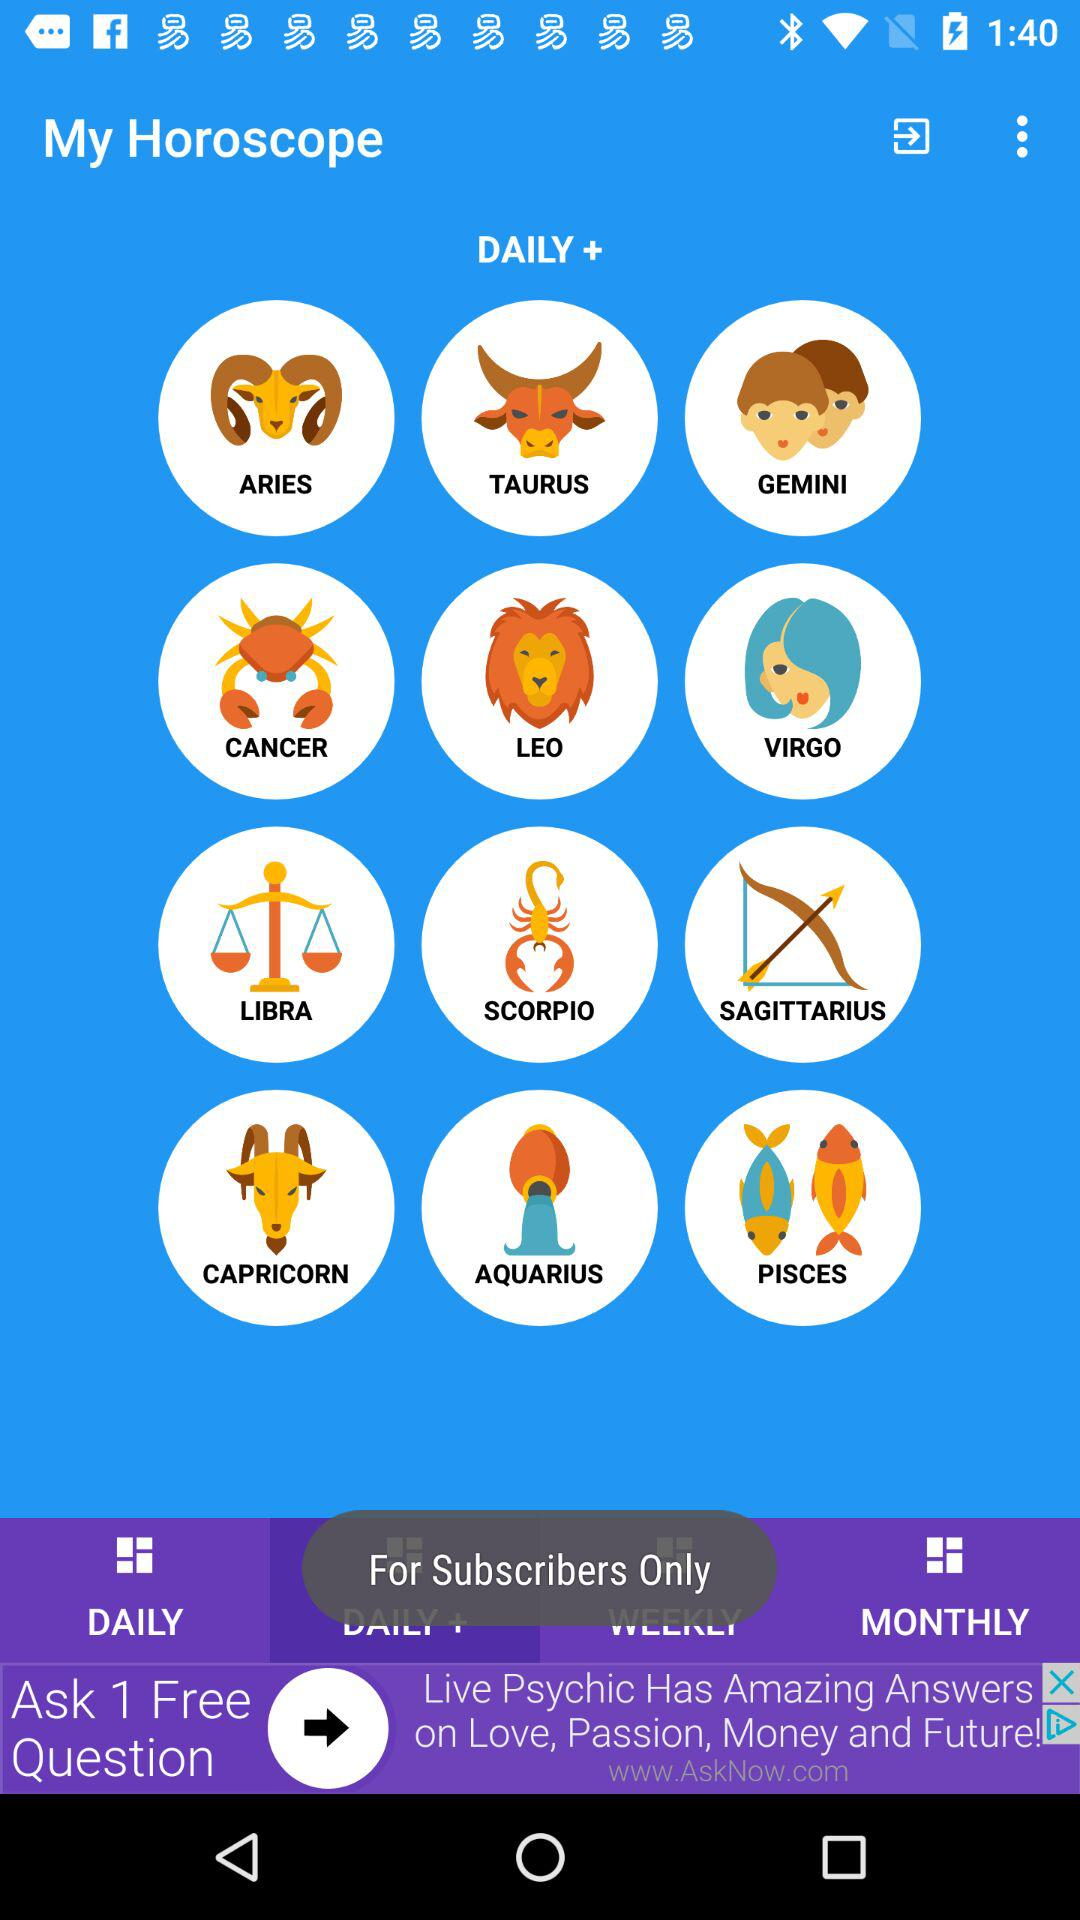How many zodiac signs are there?
Answer the question using a single word or phrase. 12 